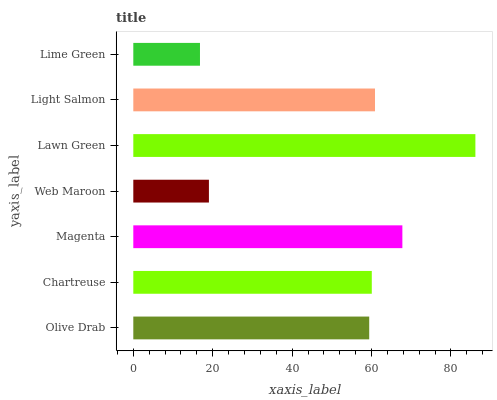Is Lime Green the minimum?
Answer yes or no. Yes. Is Lawn Green the maximum?
Answer yes or no. Yes. Is Chartreuse the minimum?
Answer yes or no. No. Is Chartreuse the maximum?
Answer yes or no. No. Is Chartreuse greater than Olive Drab?
Answer yes or no. Yes. Is Olive Drab less than Chartreuse?
Answer yes or no. Yes. Is Olive Drab greater than Chartreuse?
Answer yes or no. No. Is Chartreuse less than Olive Drab?
Answer yes or no. No. Is Chartreuse the high median?
Answer yes or no. Yes. Is Chartreuse the low median?
Answer yes or no. Yes. Is Lime Green the high median?
Answer yes or no. No. Is Web Maroon the low median?
Answer yes or no. No. 